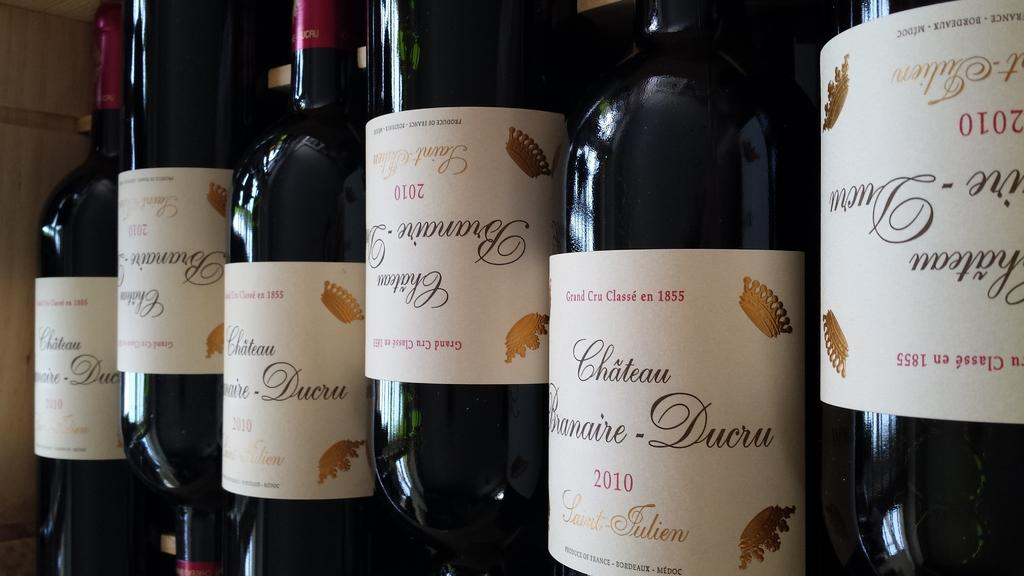<image>
Provide a brief description of the given image. Several bottles of Chateau Branaire-Ducru wine lined up next to each other. 